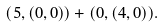Convert formula to latex. <formula><loc_0><loc_0><loc_500><loc_500>( 5 , ( 0 , 0 ) ) + ( 0 , ( 4 , 0 ) ) .</formula> 